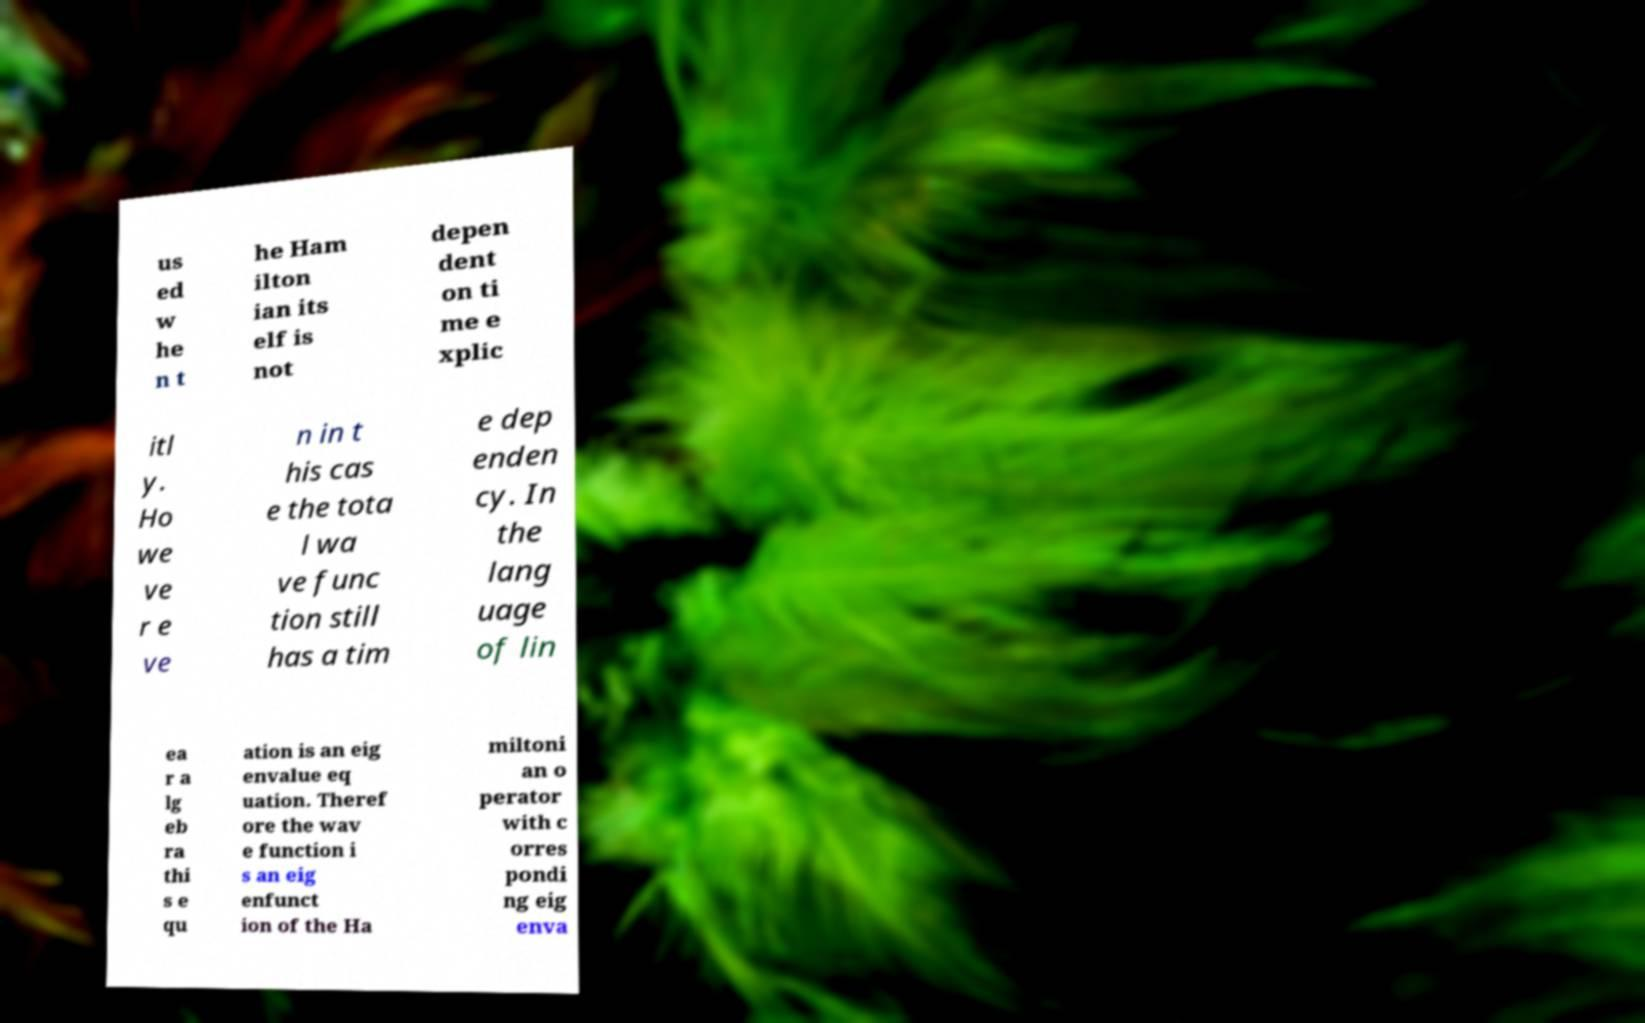Can you accurately transcribe the text from the provided image for me? us ed w he n t he Ham ilton ian its elf is not depen dent on ti me e xplic itl y. Ho we ve r e ve n in t his cas e the tota l wa ve func tion still has a tim e dep enden cy. In the lang uage of lin ea r a lg eb ra thi s e qu ation is an eig envalue eq uation. Theref ore the wav e function i s an eig enfunct ion of the Ha miltoni an o perator with c orres pondi ng eig enva 